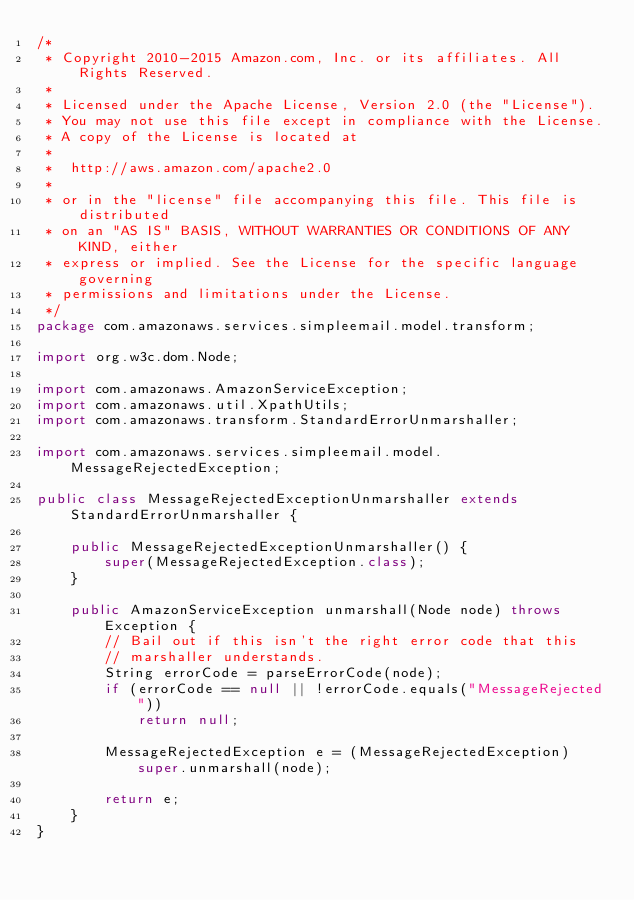Convert code to text. <code><loc_0><loc_0><loc_500><loc_500><_Java_>/*
 * Copyright 2010-2015 Amazon.com, Inc. or its affiliates. All Rights Reserved.
 * 
 * Licensed under the Apache License, Version 2.0 (the "License").
 * You may not use this file except in compliance with the License.
 * A copy of the License is located at
 * 
 *  http://aws.amazon.com/apache2.0
 * 
 * or in the "license" file accompanying this file. This file is distributed
 * on an "AS IS" BASIS, WITHOUT WARRANTIES OR CONDITIONS OF ANY KIND, either
 * express or implied. See the License for the specific language governing
 * permissions and limitations under the License.
 */
package com.amazonaws.services.simpleemail.model.transform;

import org.w3c.dom.Node;

import com.amazonaws.AmazonServiceException;
import com.amazonaws.util.XpathUtils;
import com.amazonaws.transform.StandardErrorUnmarshaller;

import com.amazonaws.services.simpleemail.model.MessageRejectedException;

public class MessageRejectedExceptionUnmarshaller extends StandardErrorUnmarshaller {

    public MessageRejectedExceptionUnmarshaller() {
        super(MessageRejectedException.class);
    }

    public AmazonServiceException unmarshall(Node node) throws Exception {
        // Bail out if this isn't the right error code that this
        // marshaller understands.
        String errorCode = parseErrorCode(node);
        if (errorCode == null || !errorCode.equals("MessageRejected"))
            return null;

        MessageRejectedException e = (MessageRejectedException)super.unmarshall(node);
        
        return e;
    }
}
    </code> 